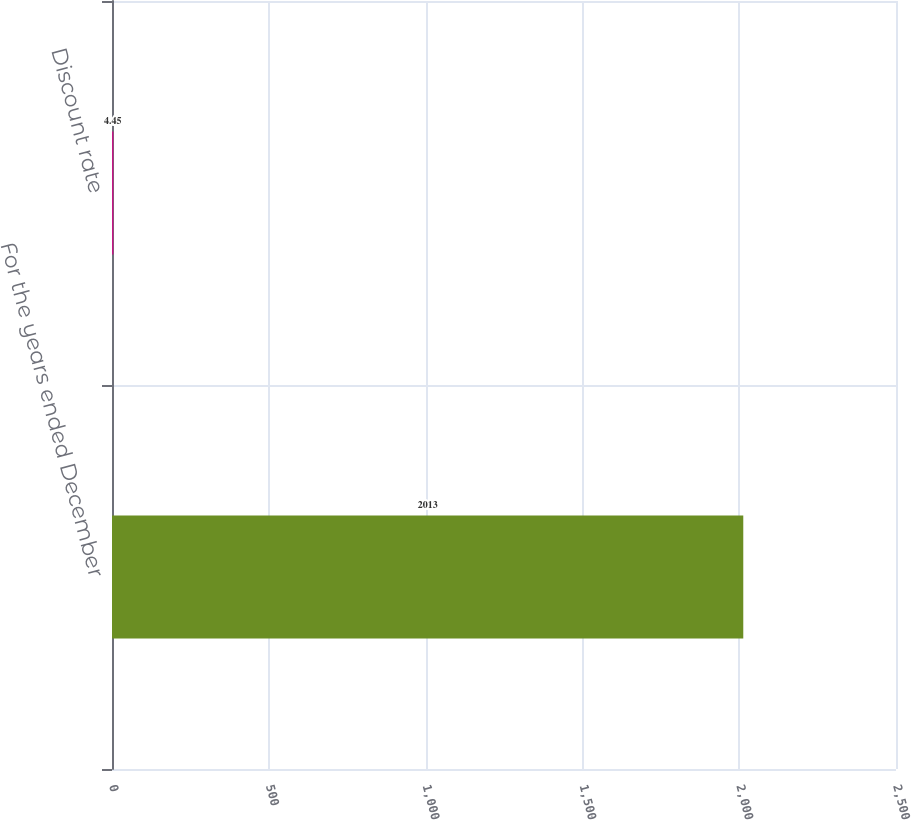Convert chart. <chart><loc_0><loc_0><loc_500><loc_500><bar_chart><fcel>For the years ended December<fcel>Discount rate<nl><fcel>2013<fcel>4.45<nl></chart> 